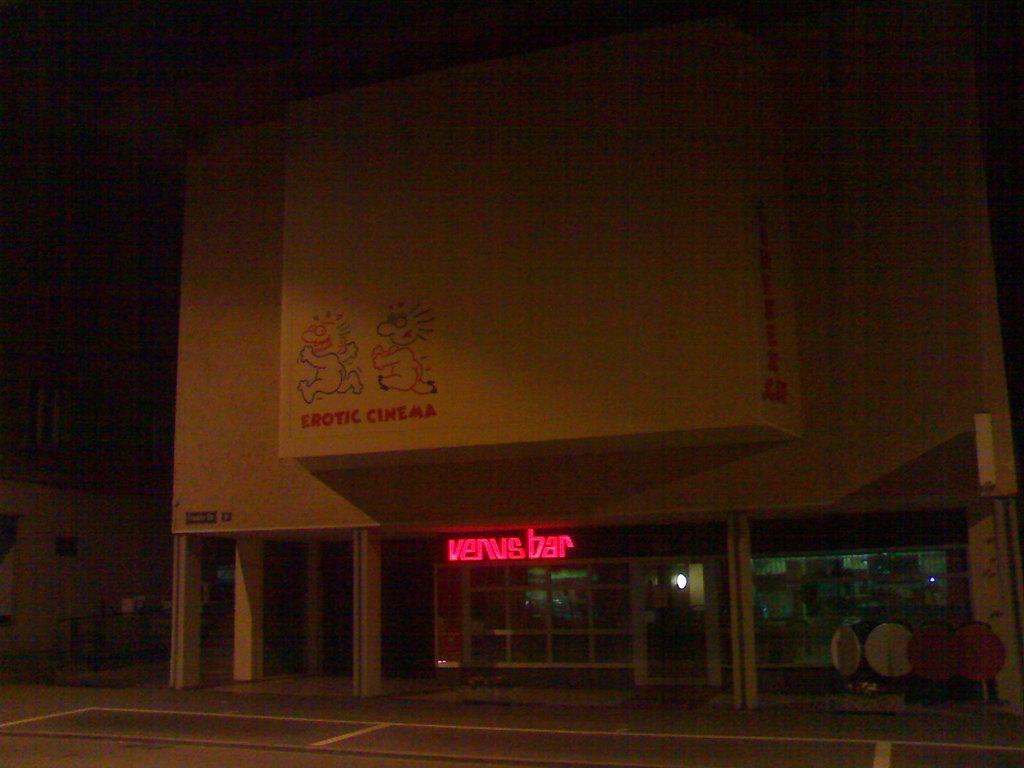In one or two sentences, can you explain what this image depicts? In this image in the background there are buildings and in the front on the right side there are objects which are white and red in colour and there is some text written on the building which is in the front. 